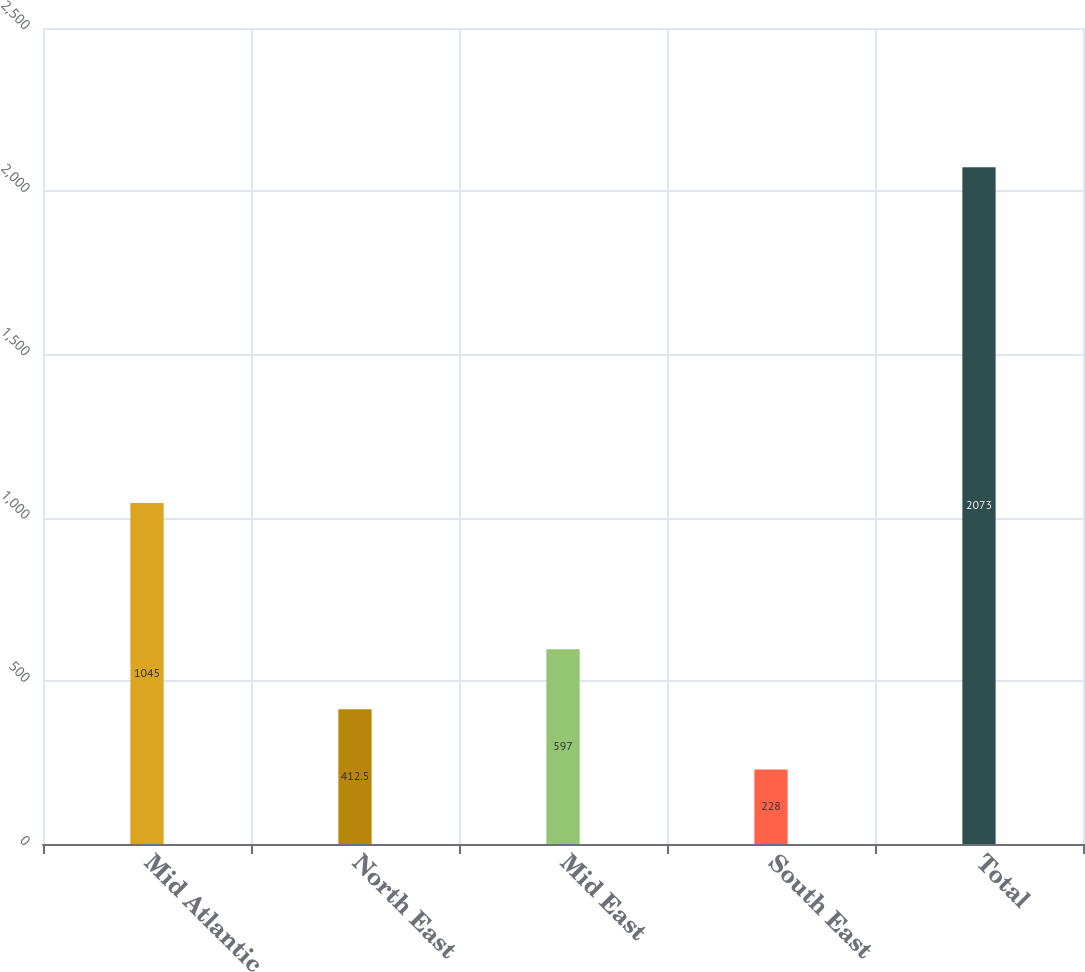Convert chart to OTSL. <chart><loc_0><loc_0><loc_500><loc_500><bar_chart><fcel>Mid Atlantic<fcel>North East<fcel>Mid East<fcel>South East<fcel>Total<nl><fcel>1045<fcel>412.5<fcel>597<fcel>228<fcel>2073<nl></chart> 